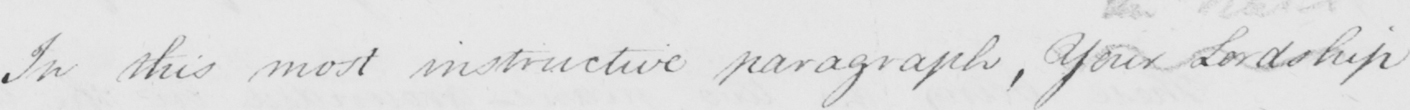Can you tell me what this handwritten text says? In this most instructive paragraph , Your Lordship 